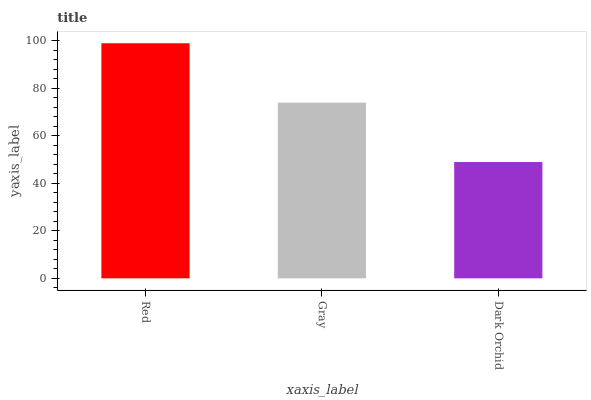Is Dark Orchid the minimum?
Answer yes or no. Yes. Is Red the maximum?
Answer yes or no. Yes. Is Gray the minimum?
Answer yes or no. No. Is Gray the maximum?
Answer yes or no. No. Is Red greater than Gray?
Answer yes or no. Yes. Is Gray less than Red?
Answer yes or no. Yes. Is Gray greater than Red?
Answer yes or no. No. Is Red less than Gray?
Answer yes or no. No. Is Gray the high median?
Answer yes or no. Yes. Is Gray the low median?
Answer yes or no. Yes. Is Dark Orchid the high median?
Answer yes or no. No. Is Red the low median?
Answer yes or no. No. 